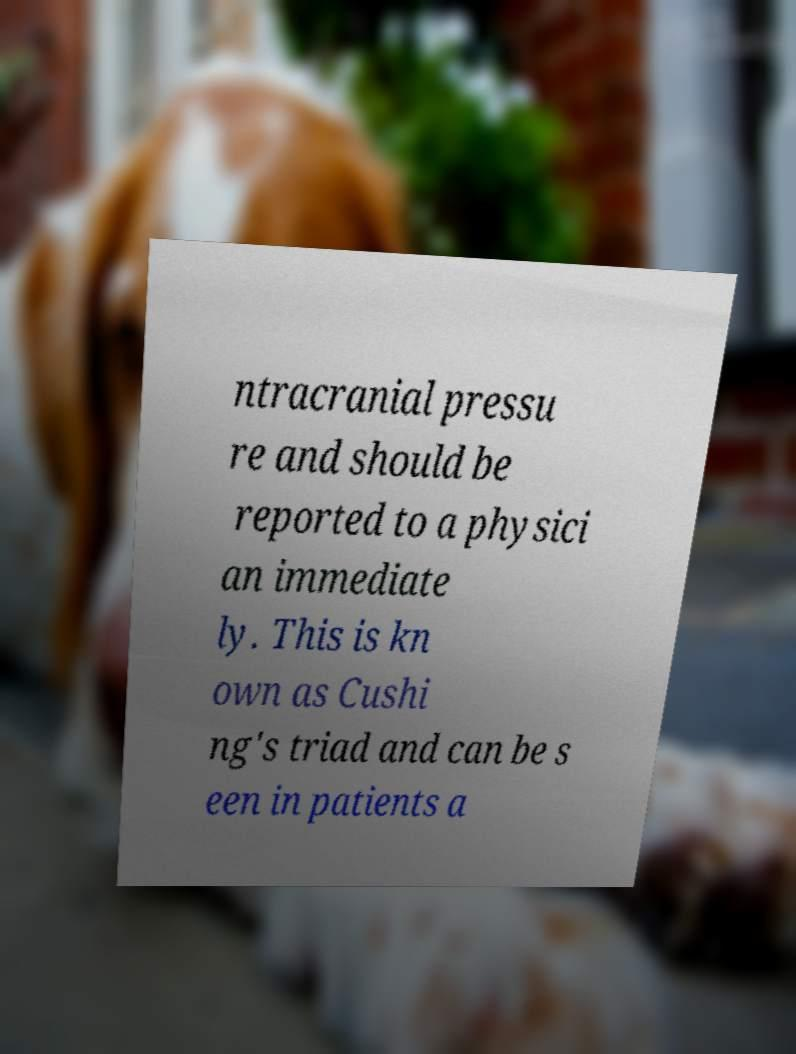For documentation purposes, I need the text within this image transcribed. Could you provide that? ntracranial pressu re and should be reported to a physici an immediate ly. This is kn own as Cushi ng's triad and can be s een in patients a 